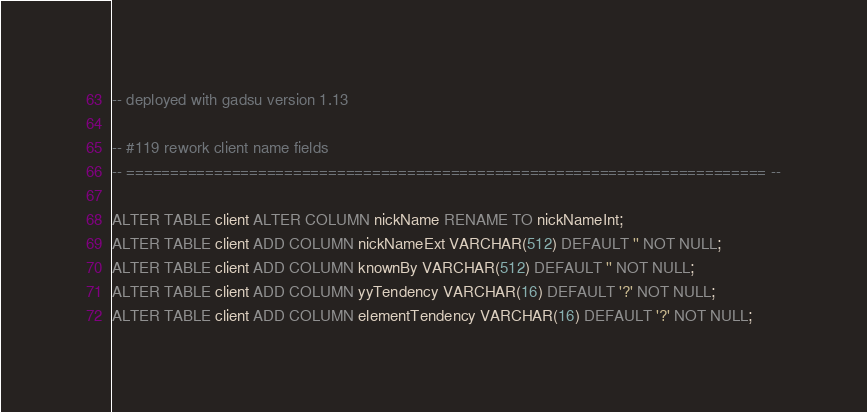<code> <loc_0><loc_0><loc_500><loc_500><_SQL_>
-- deployed with gadsu version 1.13

-- #119 rework client name fields
-- ========================================================================= --

ALTER TABLE client ALTER COLUMN nickName RENAME TO nickNameInt;
ALTER TABLE client ADD COLUMN nickNameExt VARCHAR(512) DEFAULT '' NOT NULL;
ALTER TABLE client ADD COLUMN knownBy VARCHAR(512) DEFAULT '' NOT NULL;
ALTER TABLE client ADD COLUMN yyTendency VARCHAR(16) DEFAULT '?' NOT NULL;
ALTER TABLE client ADD COLUMN elementTendency VARCHAR(16) DEFAULT '?' NOT NULL;
</code> 